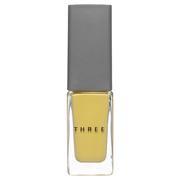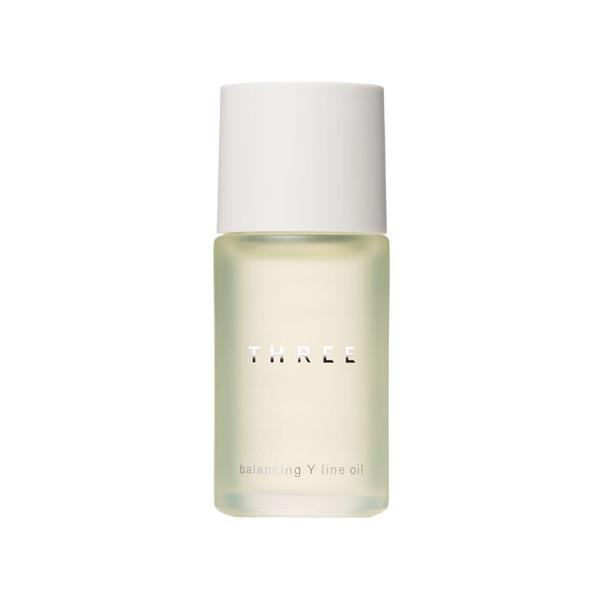The first image is the image on the left, the second image is the image on the right. Analyze the images presented: Is the assertion "One image shows an upright cylindrical bottle and the other shows a short pot-shaped product." valid? Answer yes or no. No. The first image is the image on the left, the second image is the image on the right. Assess this claim about the two images: "Each container has a round shape.". Correct or not? Answer yes or no. No. 